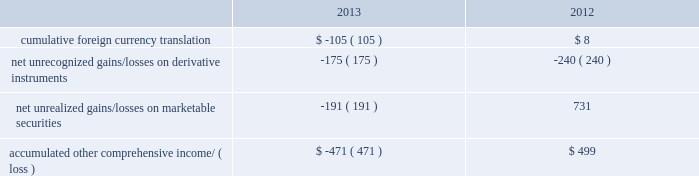Table of contents as of september 28 , 2013 .
The company 2019s share repurchase program does not obligate it to acquire any specific number of shares .
Under the program , shares may be repurchased in privately negotiated and/or open market transactions , including under plans complying with rule 10b5-1 of the securities exchange act of 1934 , as amended ( the 201cexchange act 201d ) .
In august 2012 , the company entered into an accelerated share repurchase arrangement ( 201casr 201d ) with a financial institution to purchase up to $ 1.95 billion of the company 2019s common stock in 2013 .
In the first quarter of 2013 , 2.6 million shares were initially delivered to the company .
In april 2013 , the purchase period for the asr ended and an additional 1.5 million shares were delivered to the company .
In total , 4.1 million shares were delivered under the asr at an average repurchase price of $ 478.20 per share .
The shares were retired in the quarters they were delivered , and the up-front payment of $ 1.95 billion was accounted for as a reduction to shareholders 2019 equity in the company 2019s consolidated balance sheet in the first quarter of 2013 .
In april 2013 , the company entered into a new asr program with two financial institutions to purchase up to $ 12 billion of the company 2019s common stock .
In exchange for up-front payments totaling $ 12 billion , the financial institutions committed to deliver shares during the asr 2019s purchase periods , which will end during 2014 .
The total number of shares ultimately delivered , and therefore the average price paid per share , will be determined at the end of the applicable purchase period based on the volume weighted average price of the company 2019s stock during that period .
During the third quarter of 2013 , 23.5 million shares were initially delivered to the company and retired .
This does not represent the final number of shares to be delivered under the asr .
The up-front payments of $ 12 billion were accounted for as a reduction to shareholders 2019 equity in the company 2019s consolidated balance sheet .
The company reflected the asrs as a repurchase of common stock for purposes of calculating earnings per share and as forward contracts indexed to its own common stock .
The forward contracts met all of the applicable criteria for equity classification , and , therefore , were not accounted for as derivative instruments .
During 2013 , the company repurchased 19.4 million shares of its common stock in the open market at an average price of $ 464.11 per share for a total of $ 9.0 billion .
These shares were retired upon repurchase .
Note 8 2013 comprehensive income comprehensive income consists of two components , net income and other comprehensive income .
Other comprehensive income refers to revenue , expenses , and gains and losses that under gaap are recorded as an element of shareholders 2019 equity but are excluded from net income .
The company 2019s other comprehensive income consists of foreign currency translation adjustments from those subsidiaries not using the u.s .
Dollar as their functional currency , net deferred gains and losses on certain derivative instruments accounted for as cash flow hedges , and unrealized gains and losses on marketable securities classified as available-for-sale .
The table shows the components of aoci , net of taxes , as of september 28 , 2013 and september 29 , 2012 ( in millions ) : .

Excluding cumulative foreign currency translation in 2012 , what would the balance of \\naccumulated other comprehensive income/ ( loss ) be , in millions? 
Computations: (499 - 8)
Answer: 491.0. 